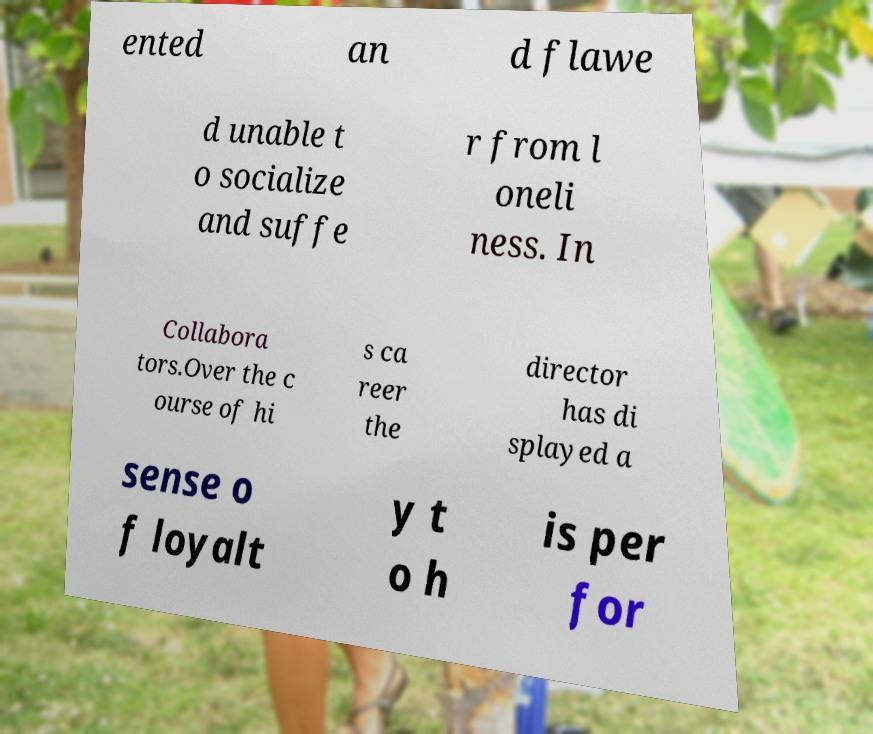For documentation purposes, I need the text within this image transcribed. Could you provide that? ented an d flawe d unable t o socialize and suffe r from l oneli ness. In Collabora tors.Over the c ourse of hi s ca reer the director has di splayed a sense o f loyalt y t o h is per for 